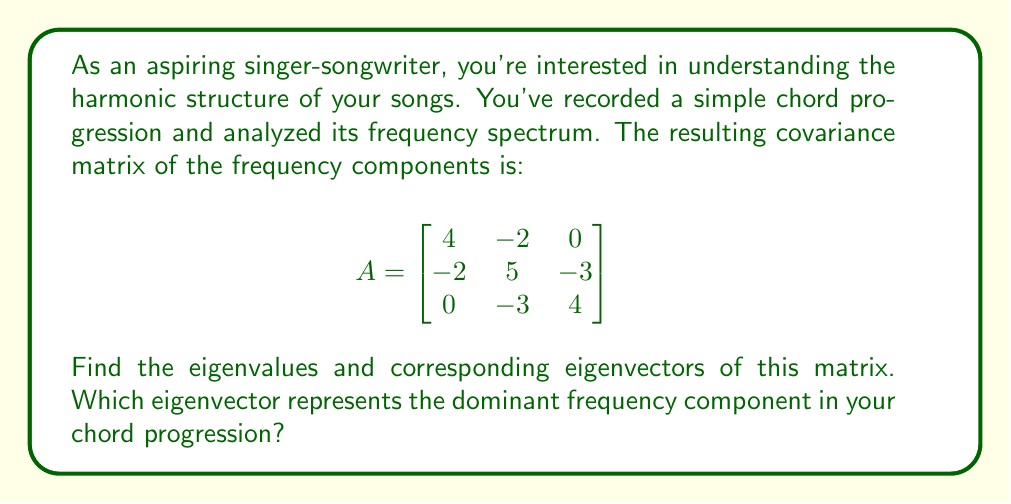Teach me how to tackle this problem. To find the eigenvalues and eigenvectors of matrix A, we follow these steps:

1) First, we find the eigenvalues by solving the characteristic equation:
   $$det(A - \lambda I) = 0$$

   $$\begin{vmatrix}
   4-\lambda & -2 & 0 \\
   -2 & 5-\lambda & -3 \\
   0 & -3 & 4-\lambda
   \end{vmatrix} = 0$$

2) Expanding this determinant:
   $$(4-\lambda)[(5-\lambda)(4-\lambda) - 9] + 2[-2(4-\lambda)] = 0$$
   $$(4-\lambda)[(20-9\lambda+\lambda^2) - 9] - 4(4-\lambda) = 0$$
   $$(4-\lambda)(11-9\lambda+\lambda^2) - 4(4-\lambda) = 0$$
   $$44-36\lambda+4\lambda^2-11\lambda+9\lambda^2-\lambda^3 - 16 + 4\lambda = 0$$
   $$-\lambda^3 + 13\lambda^2 - 43\lambda + 28 = 0$$

3) Solving this cubic equation (you can use the cubic formula or numerical methods), we get:
   $$\lambda_1 = 1, \lambda_2 = 4, \lambda_3 = 8$$

4) Now, for each eigenvalue, we find the corresponding eigenvector by solving $(A - \lambda I)v = 0$:

   For $\lambda_1 = 1$:
   $$\begin{bmatrix}
   3 & -2 & 0 \\
   -2 & 4 & -3 \\
   0 & -3 & 3
   \end{bmatrix} \begin{bmatrix} v_1 \\ v_2 \\ v_3 \end{bmatrix} = \begin{bmatrix} 0 \\ 0 \\ 0 \end{bmatrix}$$
   
   Solving this system, we get: $v_1 = \begin{bmatrix} 1 \\ 1 \\ 1 \end{bmatrix}$

   For $\lambda_2 = 4$:
   $$\begin{bmatrix}
   0 & -2 & 0 \\
   -2 & 1 & -3 \\
   0 & -3 & 0
   \end{bmatrix} \begin{bmatrix} v_1 \\ v_2 \\ v_3 \end{bmatrix} = \begin{bmatrix} 0 \\ 0 \\ 0 \end{bmatrix}$$
   
   Solving this system, we get: $v_2 = \begin{bmatrix} 1 \\ 0 \\ -\frac{2}{3} \end{bmatrix}$

   For $\lambda_3 = 8$:
   $$\begin{bmatrix}
   -4 & -2 & 0 \\
   -2 & -3 & -3 \\
   0 & -3 & -4
   \end{bmatrix} \begin{bmatrix} v_1 \\ v_2 \\ v_3 \end{bmatrix} = \begin{bmatrix} 0 \\ 0 \\ 0 \end{bmatrix}$$
   
   Solving this system, we get: $v_3 = \begin{bmatrix} -\frac{1}{2} \\ 1 \\ 1 \end{bmatrix}$

5) The eigenvector corresponding to the largest eigenvalue represents the dominant frequency component. In this case, it's $v_3$, corresponding to $\lambda_3 = 8$.
Answer: The eigenvalues are $\lambda_1 = 1$, $\lambda_2 = 4$, and $\lambda_3 = 8$.

The corresponding eigenvectors are:
$v_1 = \begin{bmatrix} 1 \\ 1 \\ 1 \end{bmatrix}$, 
$v_2 = \begin{bmatrix} 1 \\ 0 \\ -\frac{2}{3} \end{bmatrix}$, 
$v_3 = \begin{bmatrix} -\frac{1}{2} \\ 1 \\ 1 \end{bmatrix}$

The dominant frequency component is represented by $v_3 = \begin{bmatrix} -\frac{1}{2} \\ 1 \\ 1 \end{bmatrix}$, corresponding to the largest eigenvalue $\lambda_3 = 8$. 